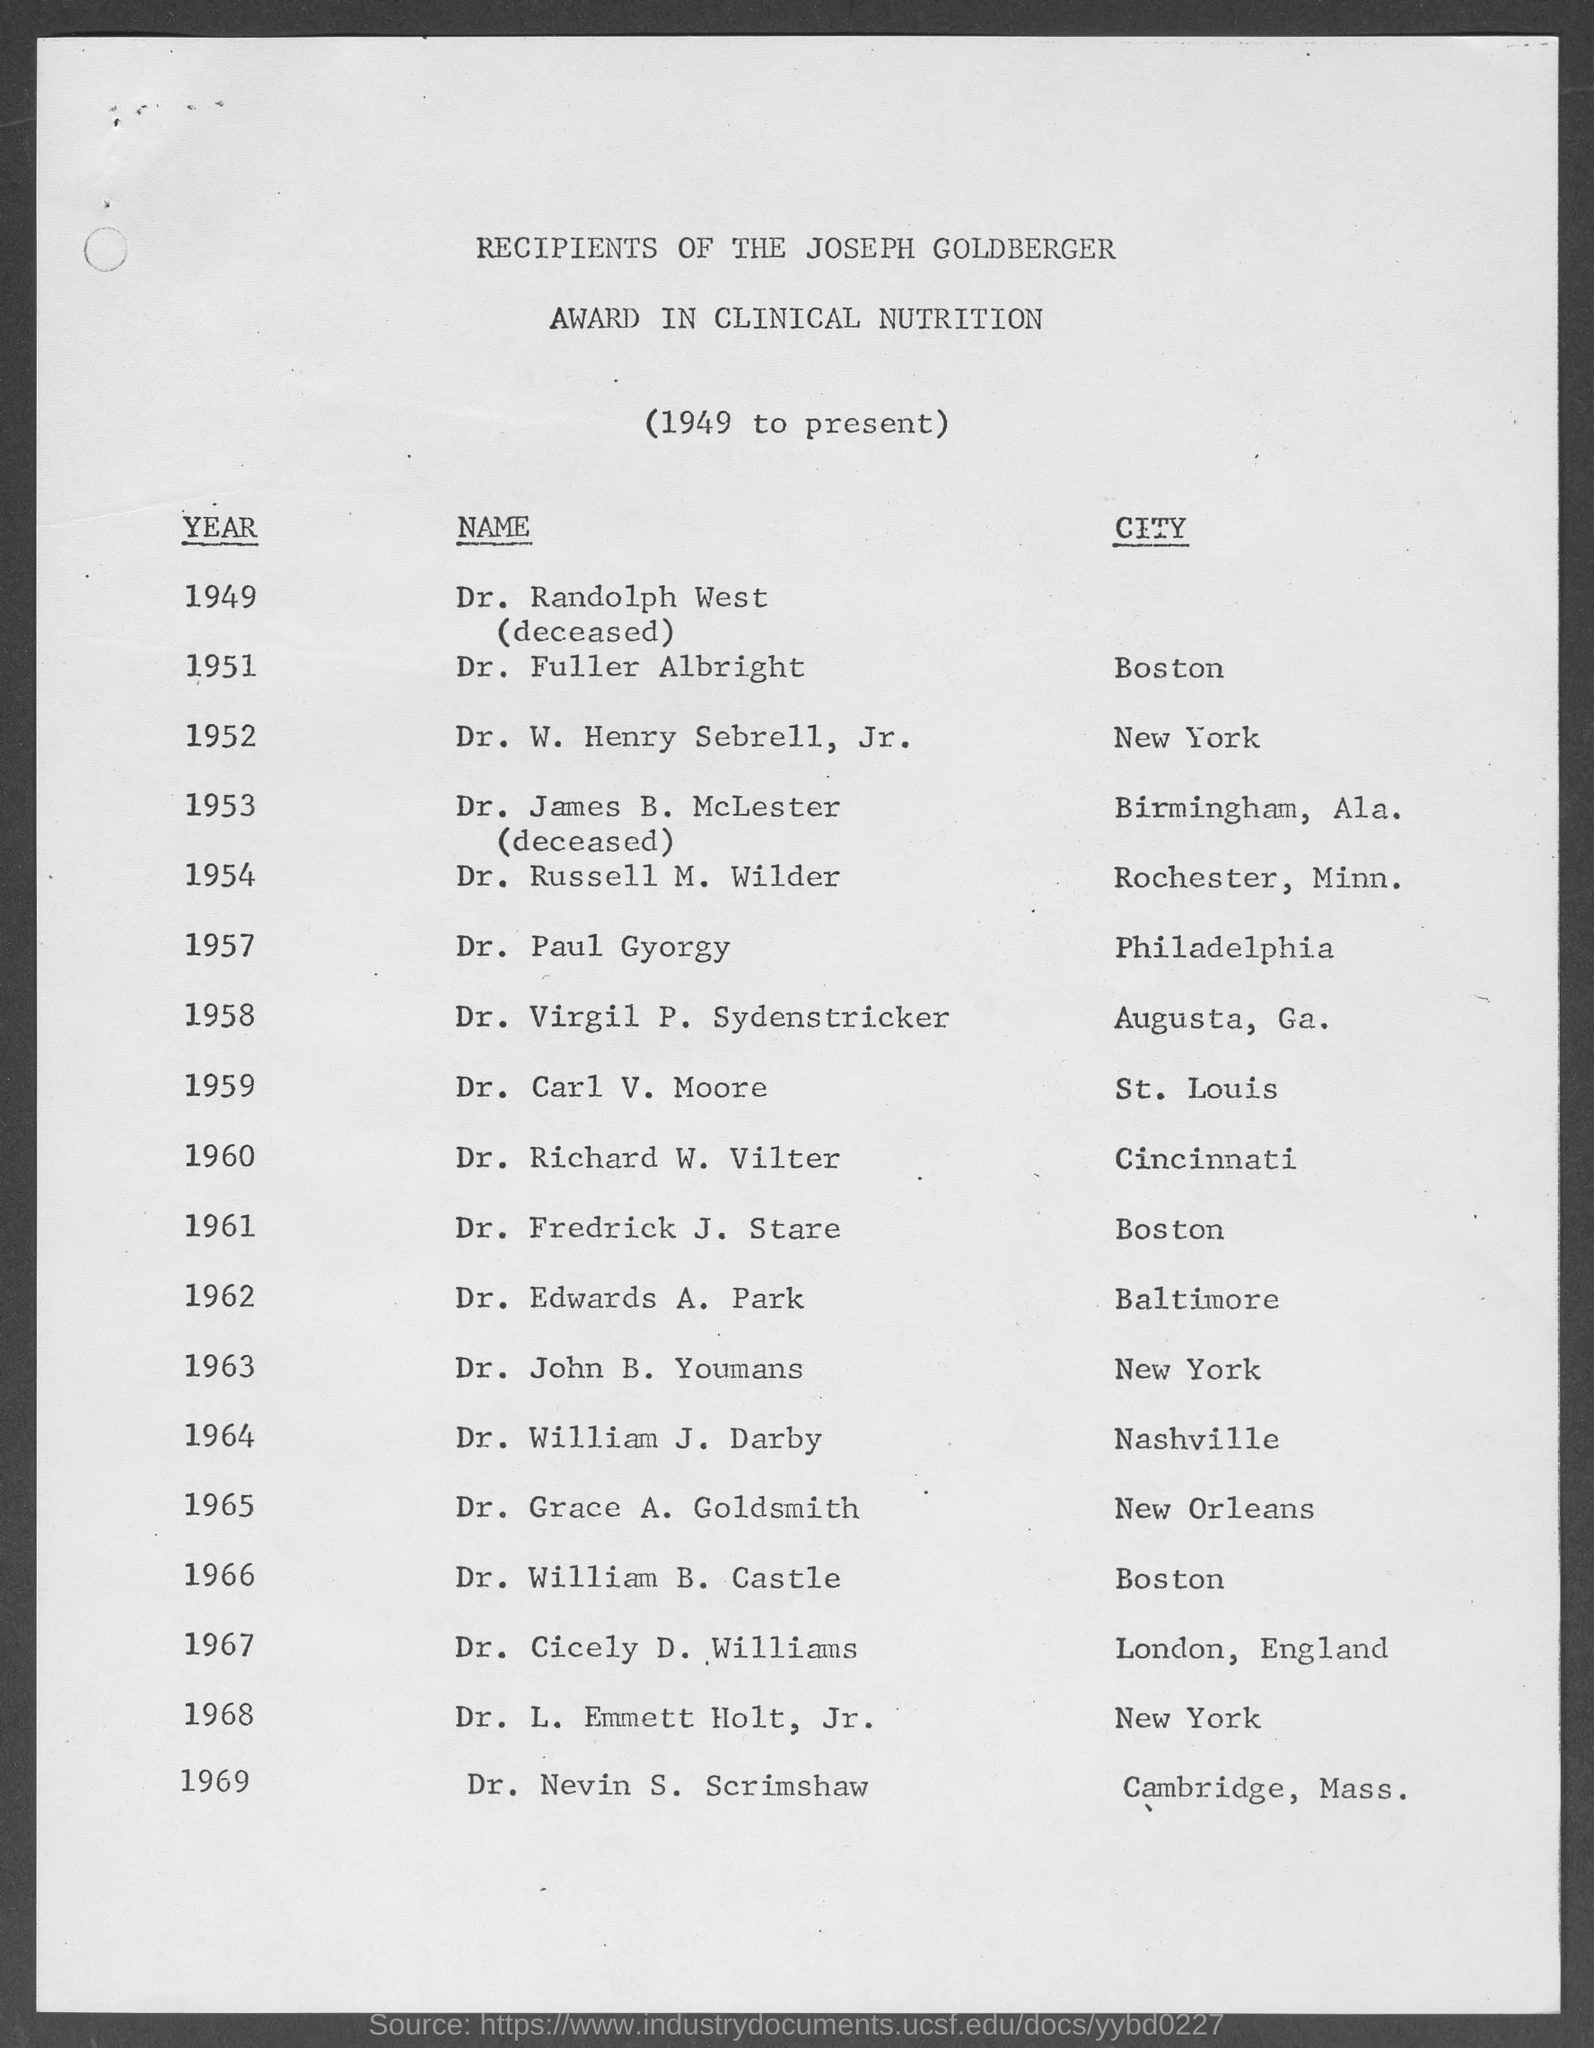Who won the Joseph Goldberger Award in Clinical Nutrition for the year 1951?
Offer a very short reply. Dr. Fuller Albright. Who won the Joseph Goldberger Award in Clinical Nutrition for the year 1957?
Provide a short and direct response. Dr. Paul Gyorgy. In which year, Dr. Carl V. Moore won the Joseph Goldberger Award?
Your answer should be compact. 1959. In which year, Dr. Edwards D. Park won the Joseph Goldberger Award?
Offer a very short reply. 1962. Who won the Joseph Goldberger Award in Clinical Nutrition for the year 1966?
Provide a succinct answer. Dr. William b. Castle. In which year, Dr. William J. Darby won the Joseph Goldberger Award?
Give a very brief answer. 1964. 